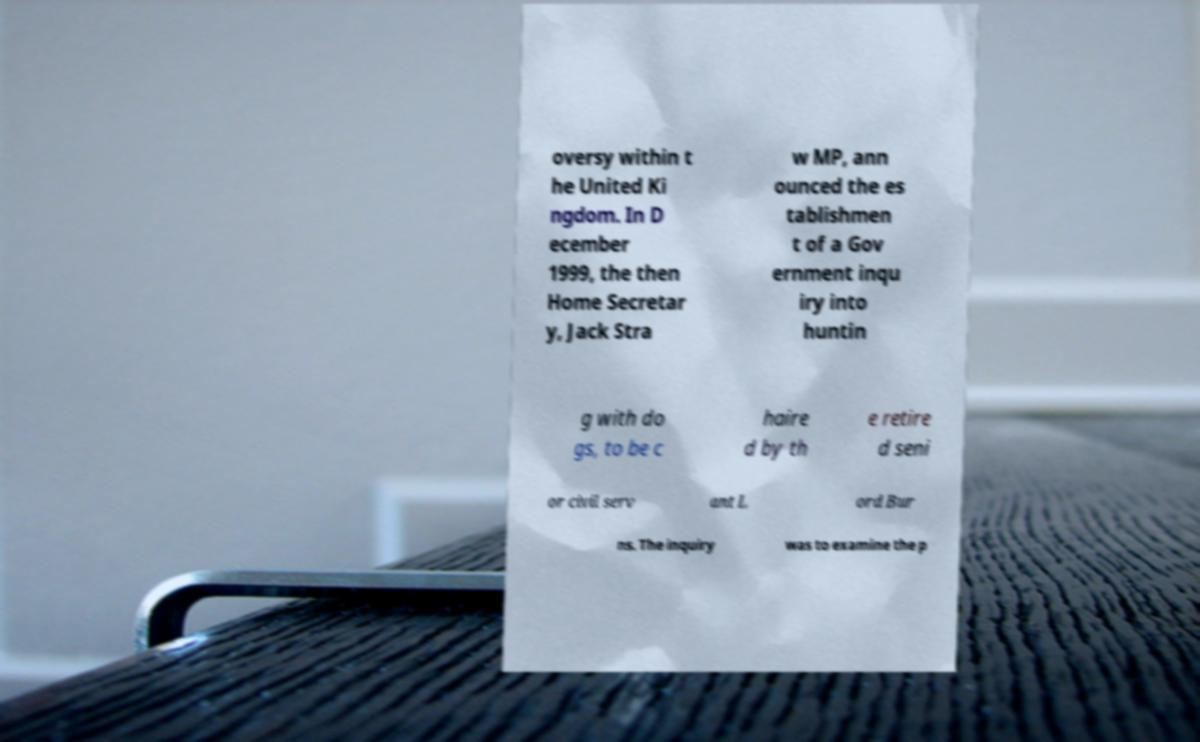Please read and relay the text visible in this image. What does it say? oversy within t he United Ki ngdom. In D ecember 1999, the then Home Secretar y, Jack Stra w MP, ann ounced the es tablishmen t of a Gov ernment inqu iry into huntin g with do gs, to be c haire d by th e retire d seni or civil serv ant L ord Bur ns. The inquiry was to examine the p 